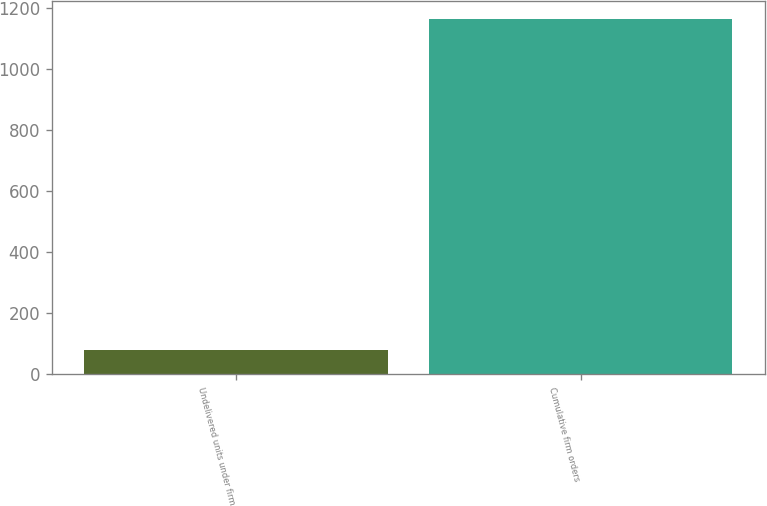<chart> <loc_0><loc_0><loc_500><loc_500><bar_chart><fcel>Undelivered units under firm<fcel>Cumulative firm orders<nl><fcel>80<fcel>1163<nl></chart> 